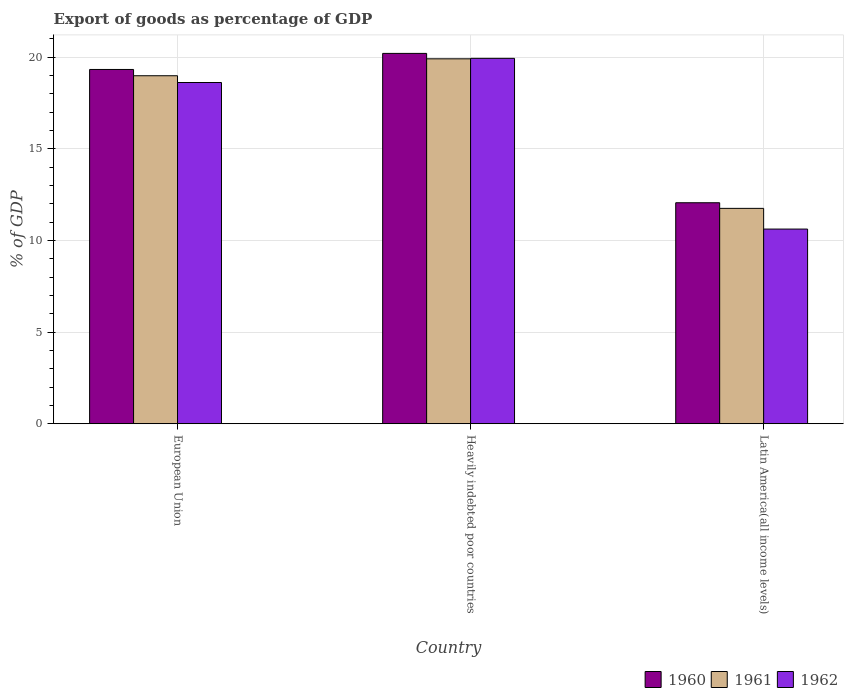How many groups of bars are there?
Provide a succinct answer. 3. Are the number of bars per tick equal to the number of legend labels?
Offer a very short reply. Yes. Are the number of bars on each tick of the X-axis equal?
Give a very brief answer. Yes. How many bars are there on the 1st tick from the right?
Provide a succinct answer. 3. What is the label of the 2nd group of bars from the left?
Provide a succinct answer. Heavily indebted poor countries. What is the export of goods as percentage of GDP in 1961 in European Union?
Your answer should be very brief. 18.98. Across all countries, what is the maximum export of goods as percentage of GDP in 1960?
Provide a succinct answer. 20.2. Across all countries, what is the minimum export of goods as percentage of GDP in 1960?
Your answer should be very brief. 12.05. In which country was the export of goods as percentage of GDP in 1962 maximum?
Give a very brief answer. Heavily indebted poor countries. In which country was the export of goods as percentage of GDP in 1960 minimum?
Provide a succinct answer. Latin America(all income levels). What is the total export of goods as percentage of GDP in 1962 in the graph?
Keep it short and to the point. 49.16. What is the difference between the export of goods as percentage of GDP in 1962 in European Union and that in Latin America(all income levels)?
Your answer should be compact. 7.99. What is the difference between the export of goods as percentage of GDP in 1962 in Latin America(all income levels) and the export of goods as percentage of GDP in 1961 in European Union?
Make the answer very short. -8.36. What is the average export of goods as percentage of GDP in 1961 per country?
Your answer should be compact. 16.88. What is the difference between the export of goods as percentage of GDP of/in 1962 and export of goods as percentage of GDP of/in 1961 in Heavily indebted poor countries?
Your answer should be very brief. 0.03. In how many countries, is the export of goods as percentage of GDP in 1962 greater than 20 %?
Your answer should be compact. 0. What is the ratio of the export of goods as percentage of GDP in 1961 in European Union to that in Latin America(all income levels)?
Offer a terse response. 1.62. What is the difference between the highest and the second highest export of goods as percentage of GDP in 1960?
Provide a short and direct response. -0.88. What is the difference between the highest and the lowest export of goods as percentage of GDP in 1962?
Your answer should be compact. 9.31. Is the sum of the export of goods as percentage of GDP in 1961 in Heavily indebted poor countries and Latin America(all income levels) greater than the maximum export of goods as percentage of GDP in 1962 across all countries?
Your response must be concise. Yes. What does the 2nd bar from the left in Heavily indebted poor countries represents?
Make the answer very short. 1961. Is it the case that in every country, the sum of the export of goods as percentage of GDP in 1960 and export of goods as percentage of GDP in 1962 is greater than the export of goods as percentage of GDP in 1961?
Provide a short and direct response. Yes. How many bars are there?
Provide a short and direct response. 9. Are all the bars in the graph horizontal?
Provide a succinct answer. No. What is the difference between two consecutive major ticks on the Y-axis?
Make the answer very short. 5. Are the values on the major ticks of Y-axis written in scientific E-notation?
Keep it short and to the point. No. Does the graph contain grids?
Your response must be concise. Yes. How many legend labels are there?
Ensure brevity in your answer.  3. What is the title of the graph?
Your answer should be compact. Export of goods as percentage of GDP. Does "2014" appear as one of the legend labels in the graph?
Your answer should be compact. No. What is the label or title of the Y-axis?
Your response must be concise. % of GDP. What is the % of GDP in 1960 in European Union?
Give a very brief answer. 19.33. What is the % of GDP of 1961 in European Union?
Ensure brevity in your answer.  18.98. What is the % of GDP in 1962 in European Union?
Your answer should be compact. 18.61. What is the % of GDP of 1960 in Heavily indebted poor countries?
Offer a very short reply. 20.2. What is the % of GDP in 1961 in Heavily indebted poor countries?
Keep it short and to the point. 19.9. What is the % of GDP in 1962 in Heavily indebted poor countries?
Give a very brief answer. 19.93. What is the % of GDP in 1960 in Latin America(all income levels)?
Offer a very short reply. 12.05. What is the % of GDP in 1961 in Latin America(all income levels)?
Your answer should be very brief. 11.75. What is the % of GDP in 1962 in Latin America(all income levels)?
Offer a terse response. 10.62. Across all countries, what is the maximum % of GDP of 1960?
Keep it short and to the point. 20.2. Across all countries, what is the maximum % of GDP of 1961?
Your response must be concise. 19.9. Across all countries, what is the maximum % of GDP in 1962?
Give a very brief answer. 19.93. Across all countries, what is the minimum % of GDP in 1960?
Your response must be concise. 12.05. Across all countries, what is the minimum % of GDP of 1961?
Your answer should be very brief. 11.75. Across all countries, what is the minimum % of GDP in 1962?
Your answer should be compact. 10.62. What is the total % of GDP in 1960 in the graph?
Offer a terse response. 51.58. What is the total % of GDP of 1961 in the graph?
Provide a short and direct response. 50.63. What is the total % of GDP of 1962 in the graph?
Keep it short and to the point. 49.16. What is the difference between the % of GDP in 1960 in European Union and that in Heavily indebted poor countries?
Offer a terse response. -0.88. What is the difference between the % of GDP of 1961 in European Union and that in Heavily indebted poor countries?
Offer a very short reply. -0.92. What is the difference between the % of GDP in 1962 in European Union and that in Heavily indebted poor countries?
Keep it short and to the point. -1.32. What is the difference between the % of GDP in 1960 in European Union and that in Latin America(all income levels)?
Offer a terse response. 7.27. What is the difference between the % of GDP of 1961 in European Union and that in Latin America(all income levels)?
Make the answer very short. 7.23. What is the difference between the % of GDP of 1962 in European Union and that in Latin America(all income levels)?
Make the answer very short. 7.99. What is the difference between the % of GDP of 1960 in Heavily indebted poor countries and that in Latin America(all income levels)?
Your response must be concise. 8.15. What is the difference between the % of GDP of 1961 in Heavily indebted poor countries and that in Latin America(all income levels)?
Offer a terse response. 8.16. What is the difference between the % of GDP of 1962 in Heavily indebted poor countries and that in Latin America(all income levels)?
Your answer should be compact. 9.31. What is the difference between the % of GDP of 1960 in European Union and the % of GDP of 1961 in Heavily indebted poor countries?
Offer a terse response. -0.58. What is the difference between the % of GDP of 1960 in European Union and the % of GDP of 1962 in Heavily indebted poor countries?
Offer a terse response. -0.61. What is the difference between the % of GDP in 1961 in European Union and the % of GDP in 1962 in Heavily indebted poor countries?
Offer a very short reply. -0.95. What is the difference between the % of GDP in 1960 in European Union and the % of GDP in 1961 in Latin America(all income levels)?
Your answer should be compact. 7.58. What is the difference between the % of GDP of 1960 in European Union and the % of GDP of 1962 in Latin America(all income levels)?
Ensure brevity in your answer.  8.71. What is the difference between the % of GDP in 1961 in European Union and the % of GDP in 1962 in Latin America(all income levels)?
Make the answer very short. 8.36. What is the difference between the % of GDP of 1960 in Heavily indebted poor countries and the % of GDP of 1961 in Latin America(all income levels)?
Offer a terse response. 8.45. What is the difference between the % of GDP of 1960 in Heavily indebted poor countries and the % of GDP of 1962 in Latin America(all income levels)?
Your answer should be very brief. 9.58. What is the difference between the % of GDP of 1961 in Heavily indebted poor countries and the % of GDP of 1962 in Latin America(all income levels)?
Give a very brief answer. 9.29. What is the average % of GDP in 1960 per country?
Make the answer very short. 17.19. What is the average % of GDP of 1961 per country?
Make the answer very short. 16.88. What is the average % of GDP in 1962 per country?
Give a very brief answer. 16.39. What is the difference between the % of GDP in 1960 and % of GDP in 1961 in European Union?
Provide a succinct answer. 0.34. What is the difference between the % of GDP in 1960 and % of GDP in 1962 in European Union?
Make the answer very short. 0.71. What is the difference between the % of GDP of 1961 and % of GDP of 1962 in European Union?
Offer a very short reply. 0.37. What is the difference between the % of GDP in 1960 and % of GDP in 1961 in Heavily indebted poor countries?
Your answer should be very brief. 0.3. What is the difference between the % of GDP in 1960 and % of GDP in 1962 in Heavily indebted poor countries?
Give a very brief answer. 0.27. What is the difference between the % of GDP of 1961 and % of GDP of 1962 in Heavily indebted poor countries?
Provide a short and direct response. -0.03. What is the difference between the % of GDP of 1960 and % of GDP of 1961 in Latin America(all income levels)?
Offer a terse response. 0.31. What is the difference between the % of GDP in 1960 and % of GDP in 1962 in Latin America(all income levels)?
Ensure brevity in your answer.  1.44. What is the difference between the % of GDP in 1961 and % of GDP in 1962 in Latin America(all income levels)?
Offer a terse response. 1.13. What is the ratio of the % of GDP of 1960 in European Union to that in Heavily indebted poor countries?
Your answer should be compact. 0.96. What is the ratio of the % of GDP in 1961 in European Union to that in Heavily indebted poor countries?
Give a very brief answer. 0.95. What is the ratio of the % of GDP of 1962 in European Union to that in Heavily indebted poor countries?
Your response must be concise. 0.93. What is the ratio of the % of GDP of 1960 in European Union to that in Latin America(all income levels)?
Your answer should be very brief. 1.6. What is the ratio of the % of GDP of 1961 in European Union to that in Latin America(all income levels)?
Offer a very short reply. 1.62. What is the ratio of the % of GDP of 1962 in European Union to that in Latin America(all income levels)?
Give a very brief answer. 1.75. What is the ratio of the % of GDP of 1960 in Heavily indebted poor countries to that in Latin America(all income levels)?
Your answer should be very brief. 1.68. What is the ratio of the % of GDP in 1961 in Heavily indebted poor countries to that in Latin America(all income levels)?
Make the answer very short. 1.69. What is the ratio of the % of GDP of 1962 in Heavily indebted poor countries to that in Latin America(all income levels)?
Give a very brief answer. 1.88. What is the difference between the highest and the second highest % of GDP of 1960?
Provide a succinct answer. 0.88. What is the difference between the highest and the second highest % of GDP of 1961?
Ensure brevity in your answer.  0.92. What is the difference between the highest and the second highest % of GDP of 1962?
Give a very brief answer. 1.32. What is the difference between the highest and the lowest % of GDP of 1960?
Your answer should be very brief. 8.15. What is the difference between the highest and the lowest % of GDP of 1961?
Offer a very short reply. 8.16. What is the difference between the highest and the lowest % of GDP in 1962?
Give a very brief answer. 9.31. 